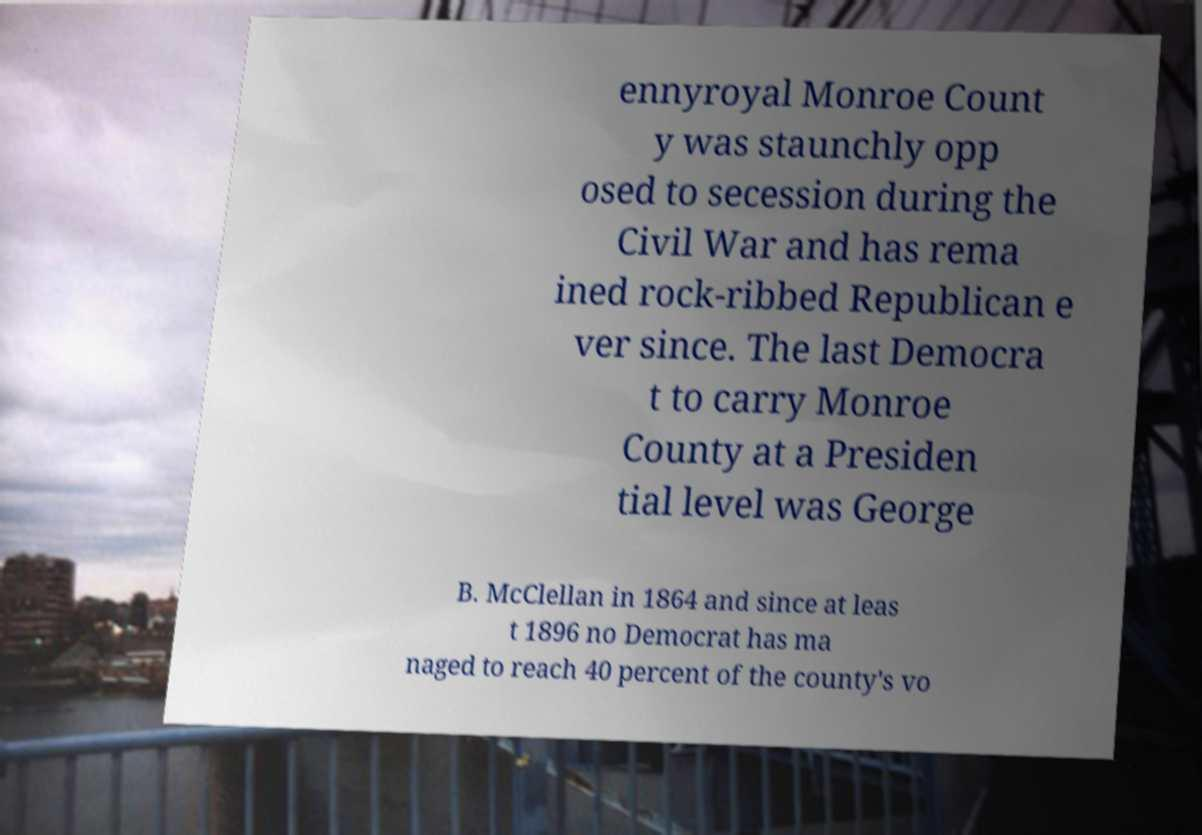There's text embedded in this image that I need extracted. Can you transcribe it verbatim? ennyroyal Monroe Count y was staunchly opp osed to secession during the Civil War and has rema ined rock-ribbed Republican e ver since. The last Democra t to carry Monroe County at a Presiden tial level was George B. McClellan in 1864 and since at leas t 1896 no Democrat has ma naged to reach 40 percent of the county's vo 